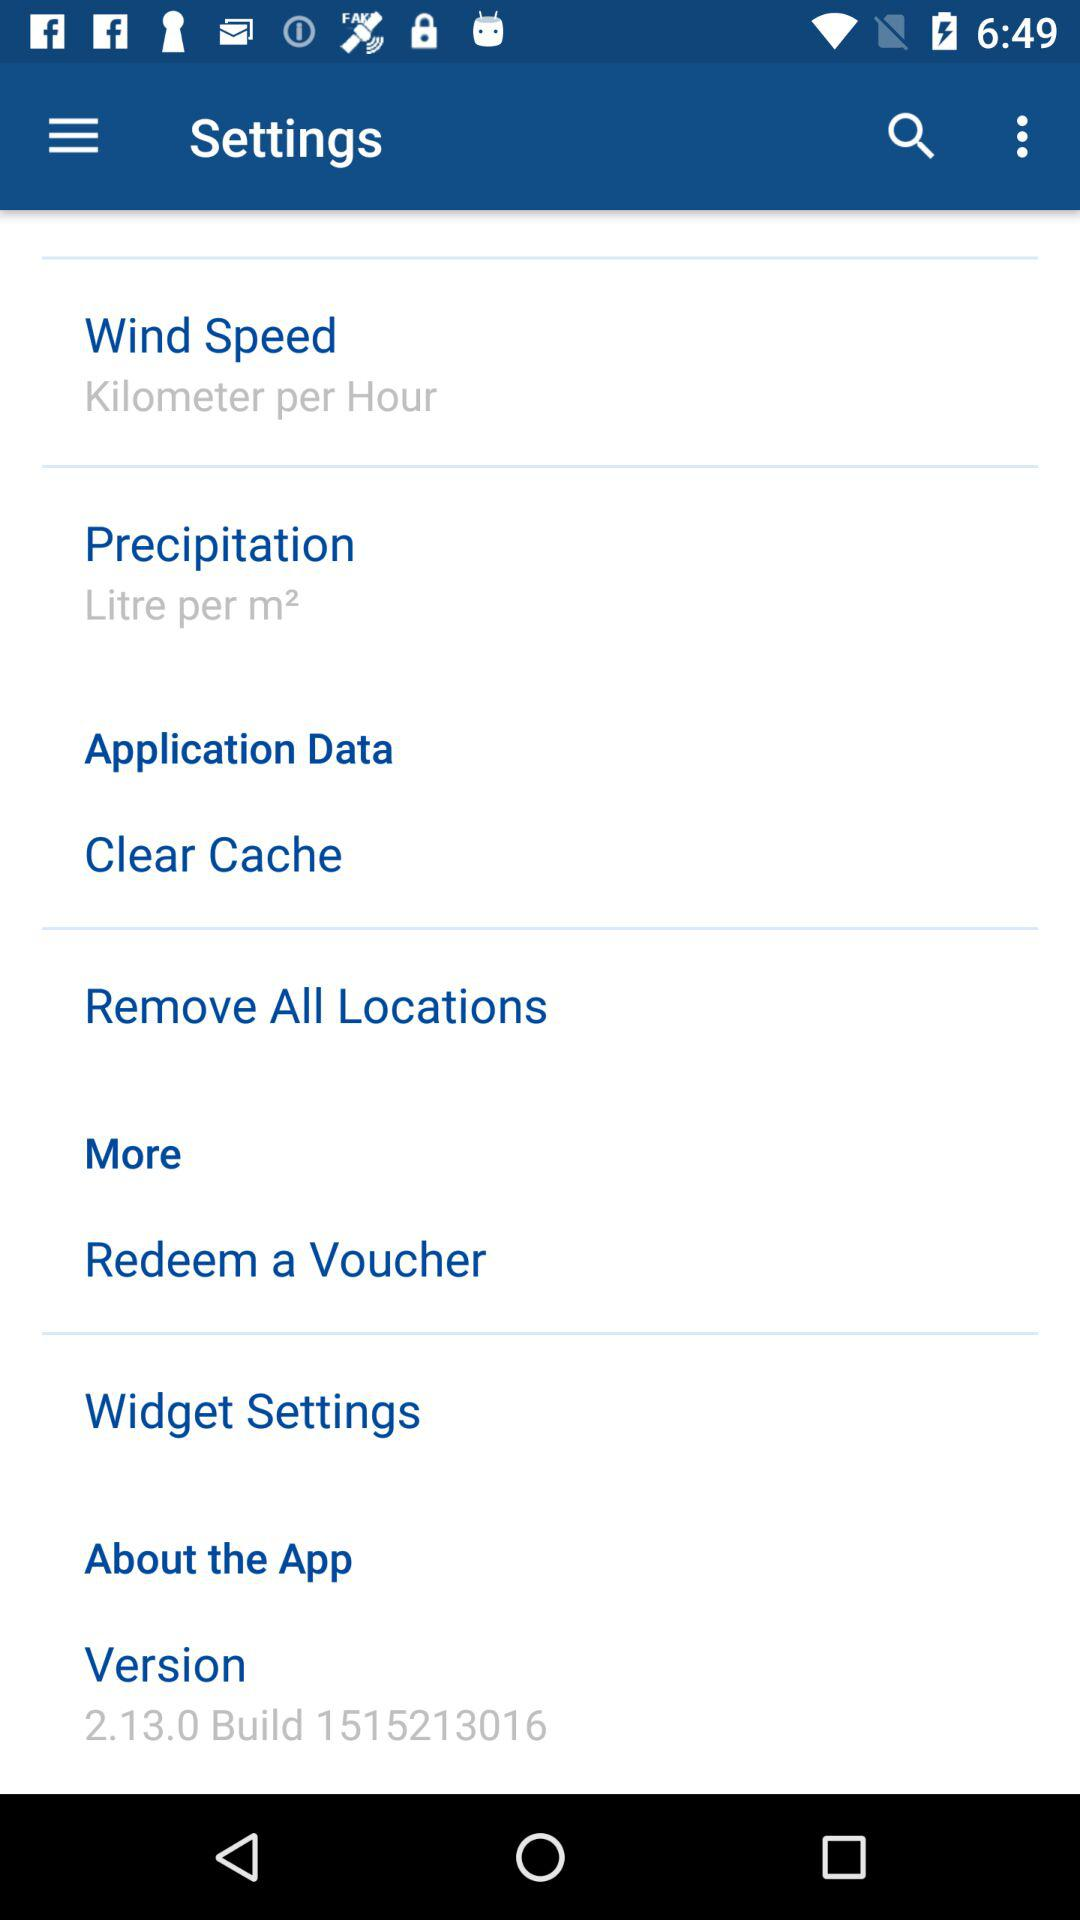What is the setting for "Wind Speed"? The setting is "Kilometer per Hour". 